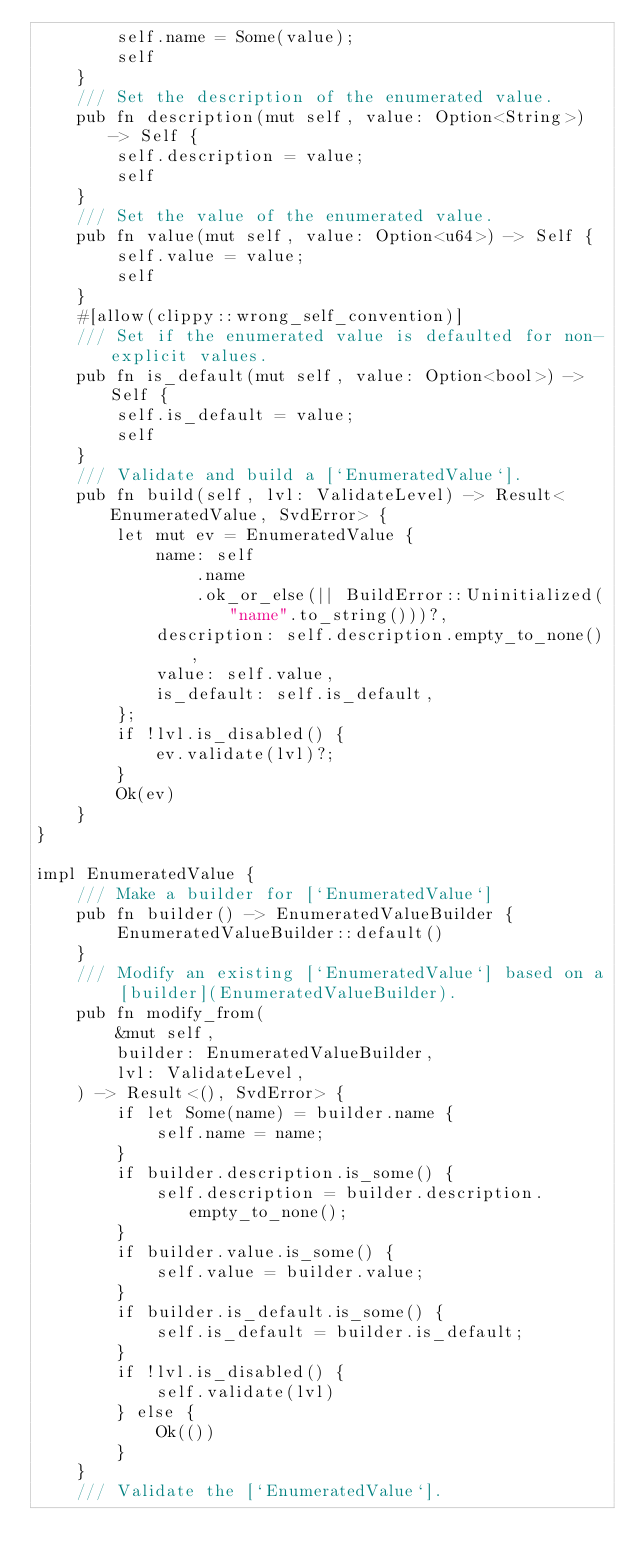Convert code to text. <code><loc_0><loc_0><loc_500><loc_500><_Rust_>        self.name = Some(value);
        self
    }
    /// Set the description of the enumerated value.
    pub fn description(mut self, value: Option<String>) -> Self {
        self.description = value;
        self
    }
    /// Set the value of the enumerated value.
    pub fn value(mut self, value: Option<u64>) -> Self {
        self.value = value;
        self
    }
    #[allow(clippy::wrong_self_convention)]
    /// Set if the enumerated value is defaulted for non-explicit values.
    pub fn is_default(mut self, value: Option<bool>) -> Self {
        self.is_default = value;
        self
    }
    /// Validate and build a [`EnumeratedValue`].
    pub fn build(self, lvl: ValidateLevel) -> Result<EnumeratedValue, SvdError> {
        let mut ev = EnumeratedValue {
            name: self
                .name
                .ok_or_else(|| BuildError::Uninitialized("name".to_string()))?,
            description: self.description.empty_to_none(),
            value: self.value,
            is_default: self.is_default,
        };
        if !lvl.is_disabled() {
            ev.validate(lvl)?;
        }
        Ok(ev)
    }
}

impl EnumeratedValue {
    /// Make a builder for [`EnumeratedValue`]
    pub fn builder() -> EnumeratedValueBuilder {
        EnumeratedValueBuilder::default()
    }
    /// Modify an existing [`EnumeratedValue`] based on a [builder](EnumeratedValueBuilder).
    pub fn modify_from(
        &mut self,
        builder: EnumeratedValueBuilder,
        lvl: ValidateLevel,
    ) -> Result<(), SvdError> {
        if let Some(name) = builder.name {
            self.name = name;
        }
        if builder.description.is_some() {
            self.description = builder.description.empty_to_none();
        }
        if builder.value.is_some() {
            self.value = builder.value;
        }
        if builder.is_default.is_some() {
            self.is_default = builder.is_default;
        }
        if !lvl.is_disabled() {
            self.validate(lvl)
        } else {
            Ok(())
        }
    }
    /// Validate the [`EnumeratedValue`].</code> 